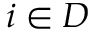<formula> <loc_0><loc_0><loc_500><loc_500>i \in D</formula> 